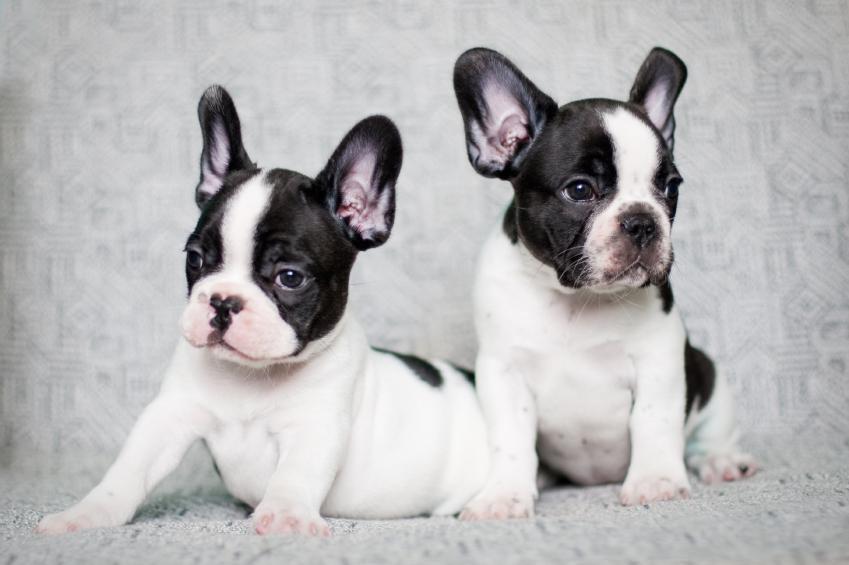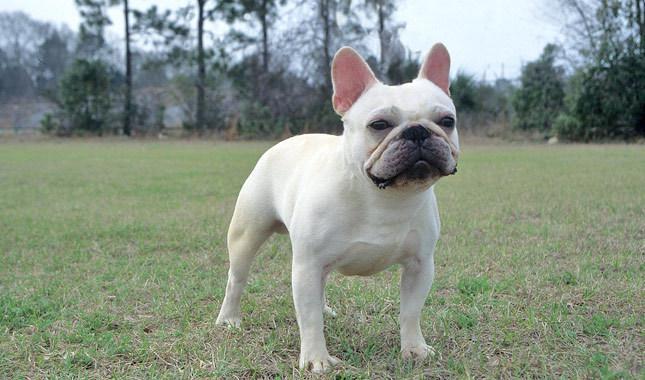The first image is the image on the left, the second image is the image on the right. For the images shown, is this caption "The dog in the image on the right is mostly black." true? Answer yes or no. No. 